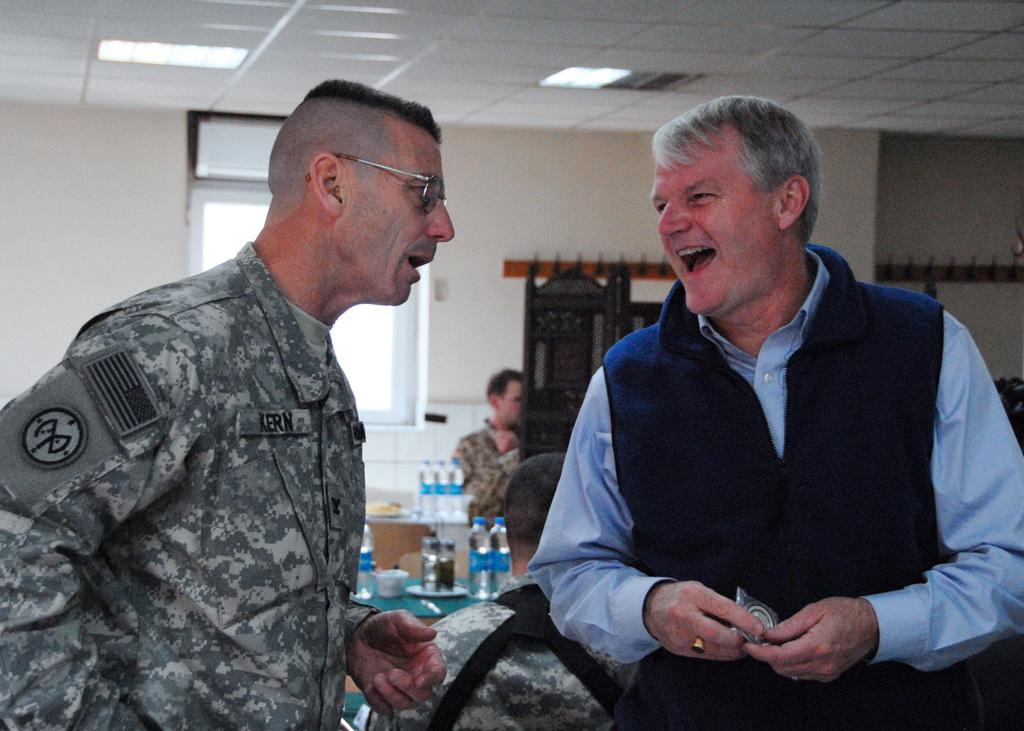What are the two persons in the image doing? The two persons in the image are talking. Can you describe the setting in which the conversation is taking place? There are other people visible in the background, and there are tables in the image. What can be found on the tables? There are bottles placed on the tables. Is there any source of natural light in the image? Yes, there is a window in the wall. How does the boy in the image say good-bye to his friends? There is no boy present in the image, so it is not possible to answer that question. 